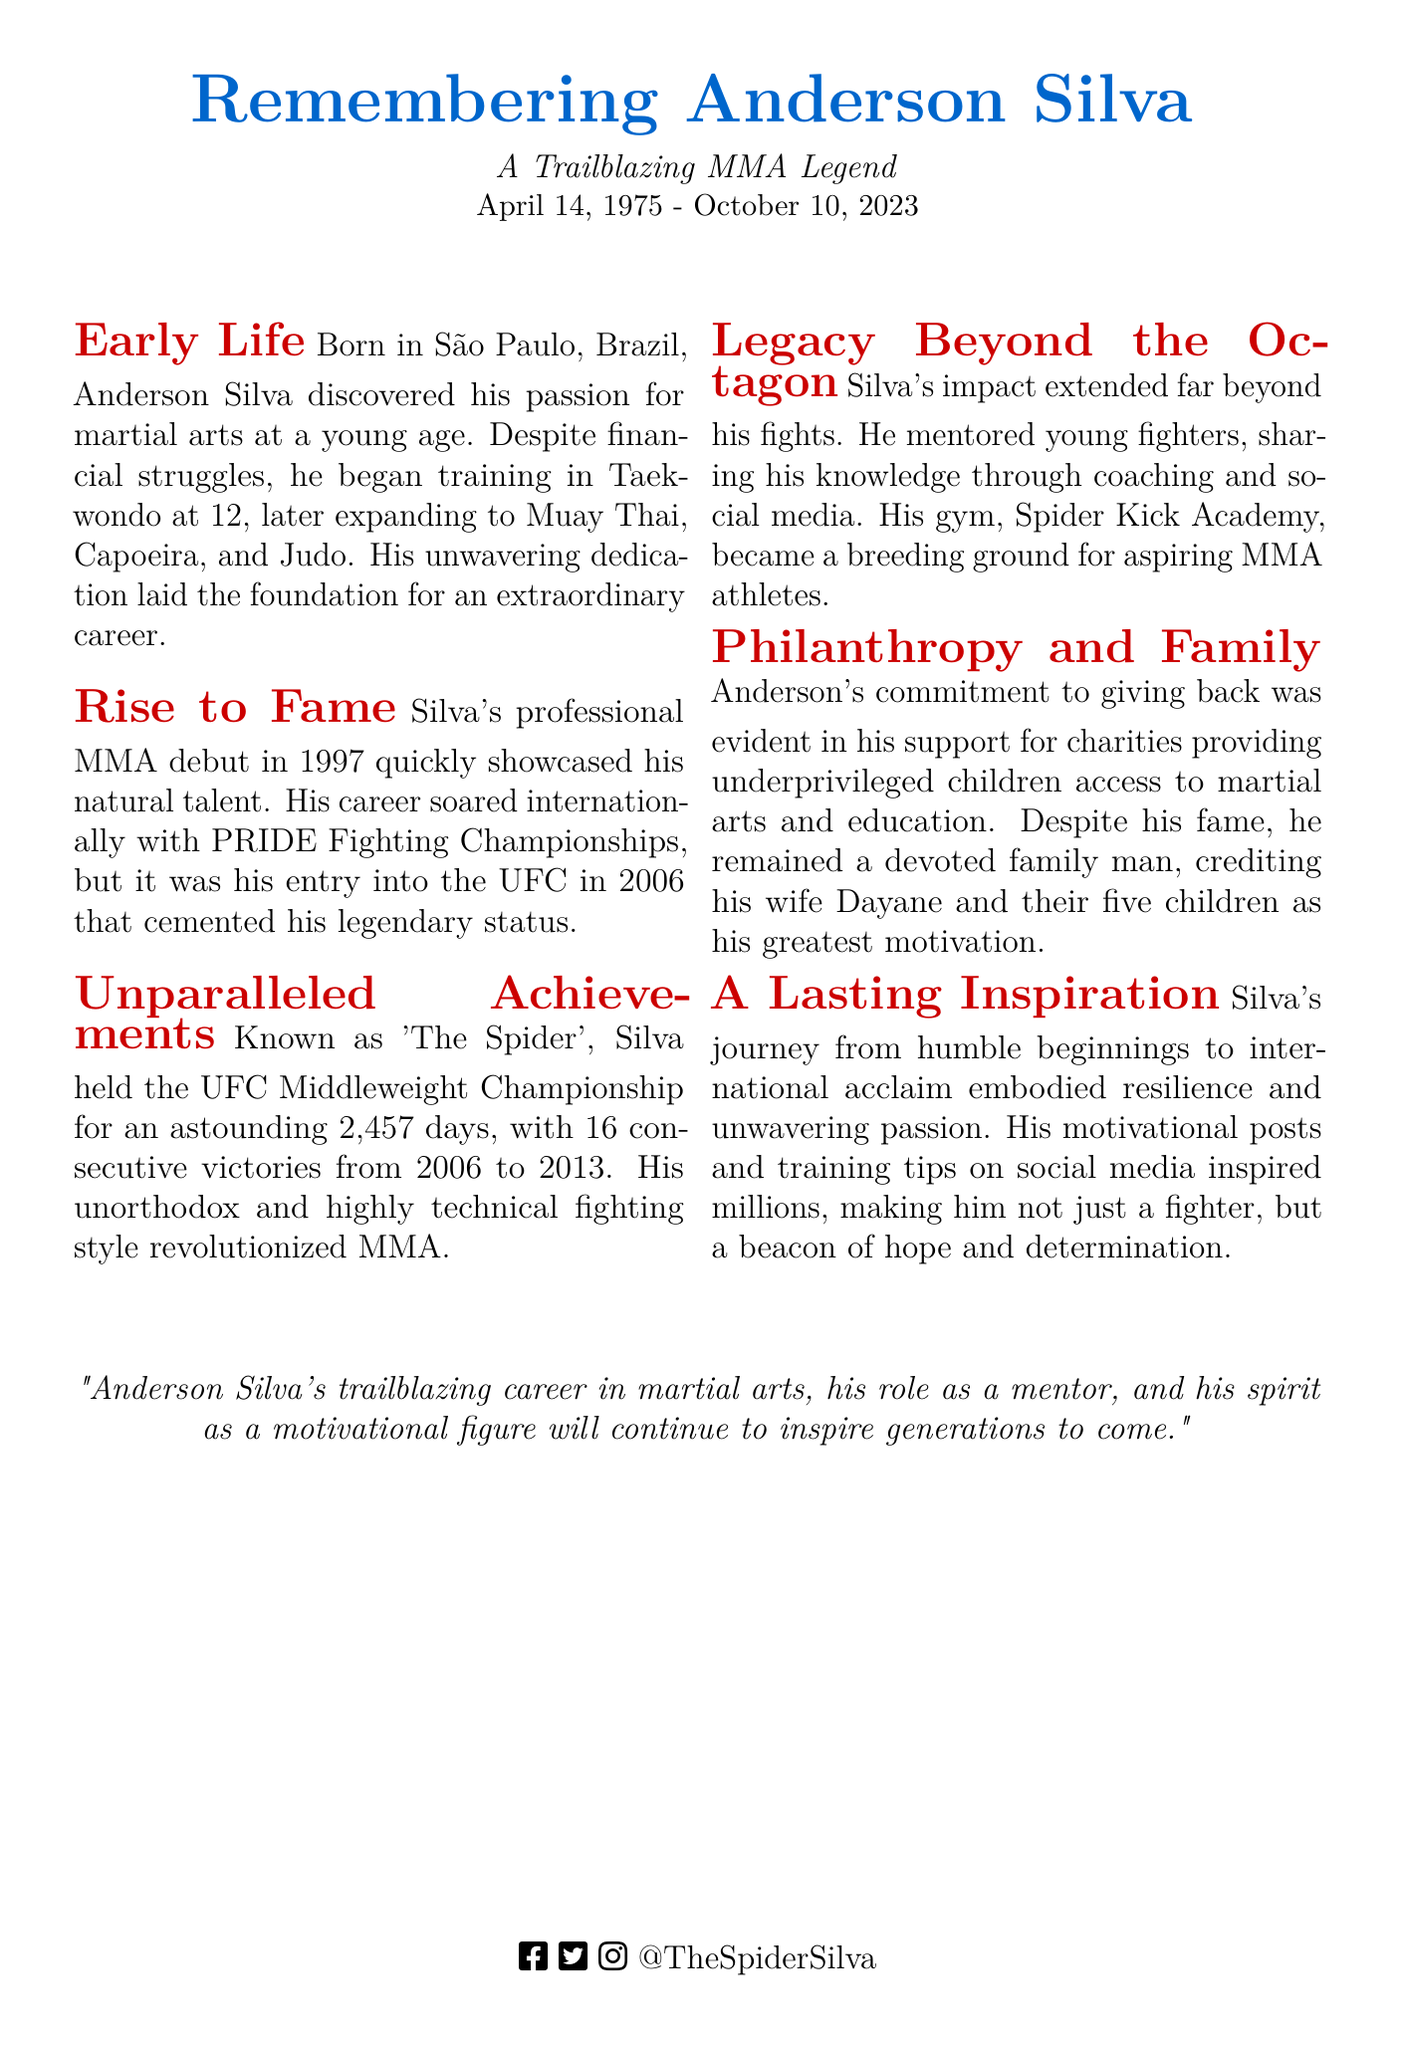What was Anderson Silva's nickname? The document refers to Anderson Silva as 'The Spider'.
Answer: The Spider In which year did Silva make his professional MMA debut? It states that Silva had his professional MMA debut in 1997.
Answer: 1997 How long did Anderson Silva hold the UFC Middleweight Championship? The document mentions that he held the title for 2,457 days.
Answer: 2,457 days What type of training did Silva start with at the age of 12? The document indicates that he began training in Taekwondo.
Answer: Taekwondo How many consecutive victories did Silva achieve from 2006 to 2013? The document states that he achieved 16 consecutive victories.
Answer: 16 What was the name of Anderson Silva's gym? The document mentions that his gym is called Spider Kick Academy.
Answer: Spider Kick Academy Which country is Anderson Silva originally from? The document states that he was born in São Paulo, Brazil.
Answer: Brazil What was Silva's greatest motivation in life according to the document? It notes that his greatest motivation was his wife Dayane and their five children.
Answer: Dayane and their five children What kind of impact did Silva have beyond his fights? The document states that he mentored young fighters and shared his knowledge.
Answer: Mentored young fighters and shared his knowledge 